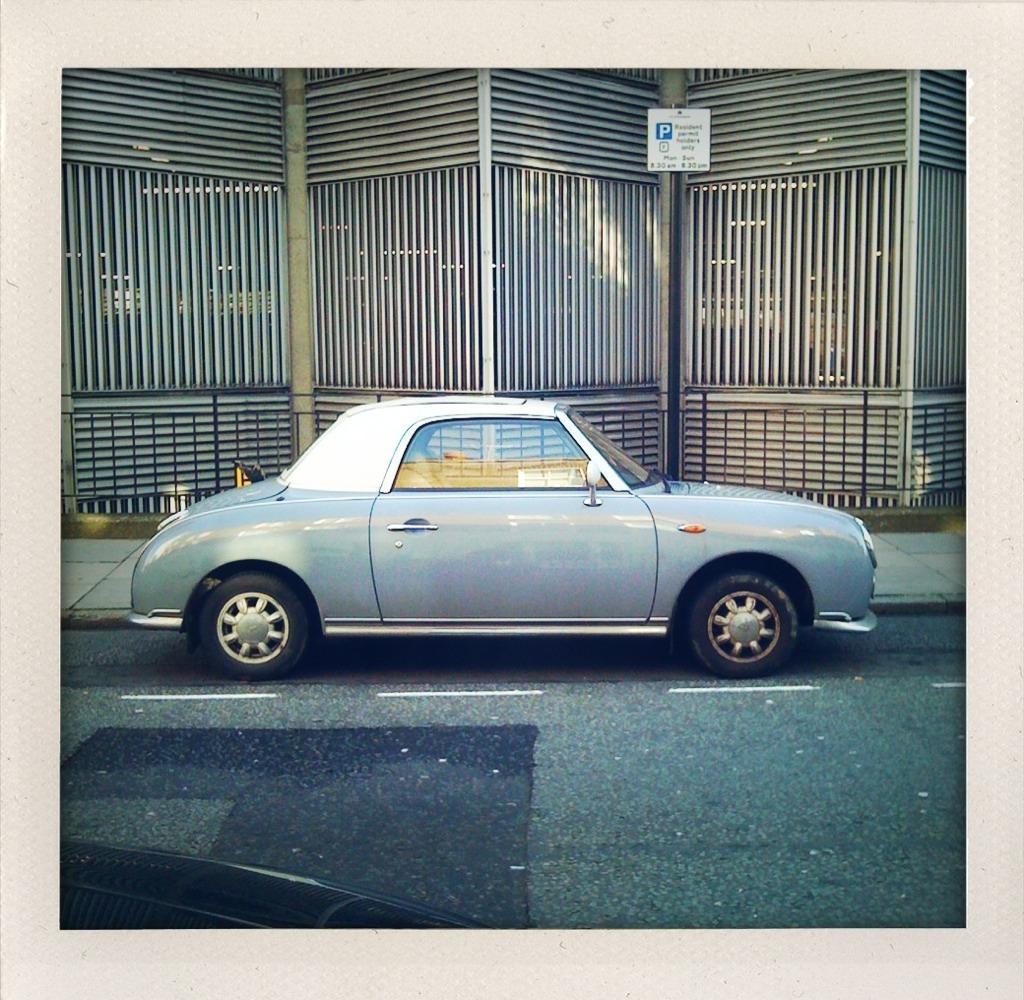Can you describe this image briefly? In this image there is a car parked on the road. Beside the road there is a walkway. In the background there is a wall of metal rods. There is a board with text on the metal rods. 